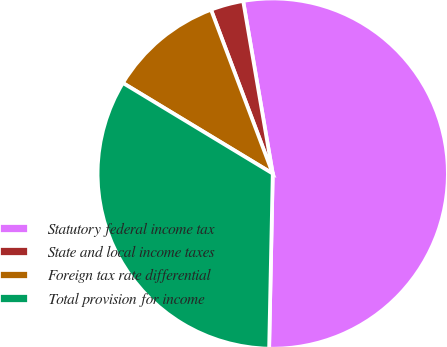Convert chart. <chart><loc_0><loc_0><loc_500><loc_500><pie_chart><fcel>Statutory federal income tax<fcel>State and local income taxes<fcel>Foreign tax rate differential<fcel>Total provision for income<nl><fcel>53.03%<fcel>3.03%<fcel>10.61%<fcel>33.33%<nl></chart> 